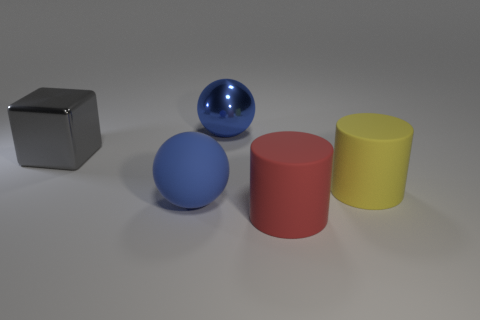How many gray cubes are there?
Your answer should be very brief. 1. What material is the other cylinder that is the same size as the red rubber cylinder?
Provide a short and direct response. Rubber. Are there any blue matte spheres of the same size as the blue metal ball?
Make the answer very short. Yes. There is a big ball on the right side of the blue matte object; does it have the same color as the big ball that is in front of the large gray object?
Provide a short and direct response. Yes. What number of matte things are either large red things or big spheres?
Your answer should be compact. 2. What number of big blue rubber spheres are in front of the big shiny object that is left of the metal thing that is behind the gray metallic object?
Give a very brief answer. 1. How many metallic objects are the same color as the metallic ball?
Your response must be concise. 0. The object that is behind the yellow cylinder and to the right of the matte sphere is what color?
Offer a terse response. Blue. What number of things are large yellow matte cylinders or cylinders that are right of the red matte cylinder?
Provide a short and direct response. 1. What material is the big blue thing in front of the matte thing that is behind the large matte sphere in front of the big metal ball made of?
Offer a very short reply. Rubber. 